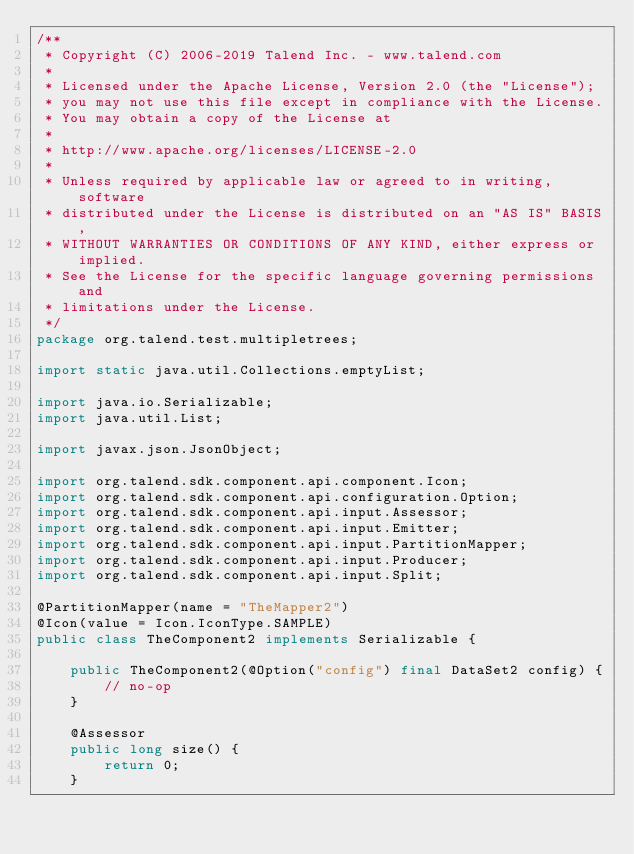<code> <loc_0><loc_0><loc_500><loc_500><_Java_>/**
 * Copyright (C) 2006-2019 Talend Inc. - www.talend.com
 *
 * Licensed under the Apache License, Version 2.0 (the "License");
 * you may not use this file except in compliance with the License.
 * You may obtain a copy of the License at
 *
 * http://www.apache.org/licenses/LICENSE-2.0
 *
 * Unless required by applicable law or agreed to in writing, software
 * distributed under the License is distributed on an "AS IS" BASIS,
 * WITHOUT WARRANTIES OR CONDITIONS OF ANY KIND, either express or implied.
 * See the License for the specific language governing permissions and
 * limitations under the License.
 */
package org.talend.test.multipletrees;

import static java.util.Collections.emptyList;

import java.io.Serializable;
import java.util.List;

import javax.json.JsonObject;

import org.talend.sdk.component.api.component.Icon;
import org.talend.sdk.component.api.configuration.Option;
import org.talend.sdk.component.api.input.Assessor;
import org.talend.sdk.component.api.input.Emitter;
import org.talend.sdk.component.api.input.PartitionMapper;
import org.talend.sdk.component.api.input.Producer;
import org.talend.sdk.component.api.input.Split;

@PartitionMapper(name = "TheMapper2")
@Icon(value = Icon.IconType.SAMPLE)
public class TheComponent2 implements Serializable {

    public TheComponent2(@Option("config") final DataSet2 config) {
        // no-op
    }

    @Assessor
    public long size() {
        return 0;
    }
</code> 